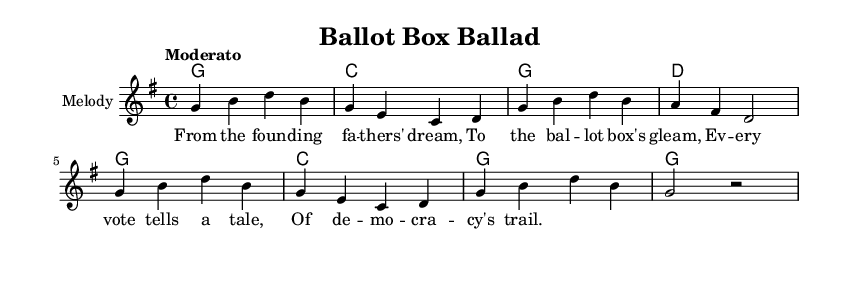What is the key signature of this music? The key signature is identified by the presence of the sharp and flat symbols at the beginning of the staff. In this case, there are no sharps or flats, indicating that it is in the key of G major.
Answer: G major What is the time signature of this music? The time signature is found at the beginning of the score, indicated by the two numbers stacked vertically. This shows that there are four beats in a measure and that the quarter note receives one beat.
Answer: 4/4 What is the tempo marking for this piece? The tempo is indicated by the word "Moderato" which means moderately fast. This suggests that the music should be played at a medium-paced speed, generally around 108 to 120 beats per minute.
Answer: Moderato How many measures are in the melody? By counting the vertical lines (bar lines) present in the melody section, we can determine the number of measures. There are six measures in total, each separated by a vertical line.
Answer: 6 What is the chord that starts the harmonies? The first chord indicated at the start of the harmony line is written at the beginning, which is a G major chord. This is represented by the letter "g" in the chord mode.
Answer: G What is the lyrical theme of the first verse? The lyrics reflect themes of democracy and the importance of voting, as expressed in phrases like "From the founding fathers' dream" and "Every vote tells a tale." This establishes a narrative related to political movements.
Answer: Democracy How many lines of lyrics are present in this verse? The provided lyrics consist of four lines, each containing a specific message related to the theme of voting and democracy. The structure shows a consistent pattern and emphasizes the narrative.
Answer: 4 